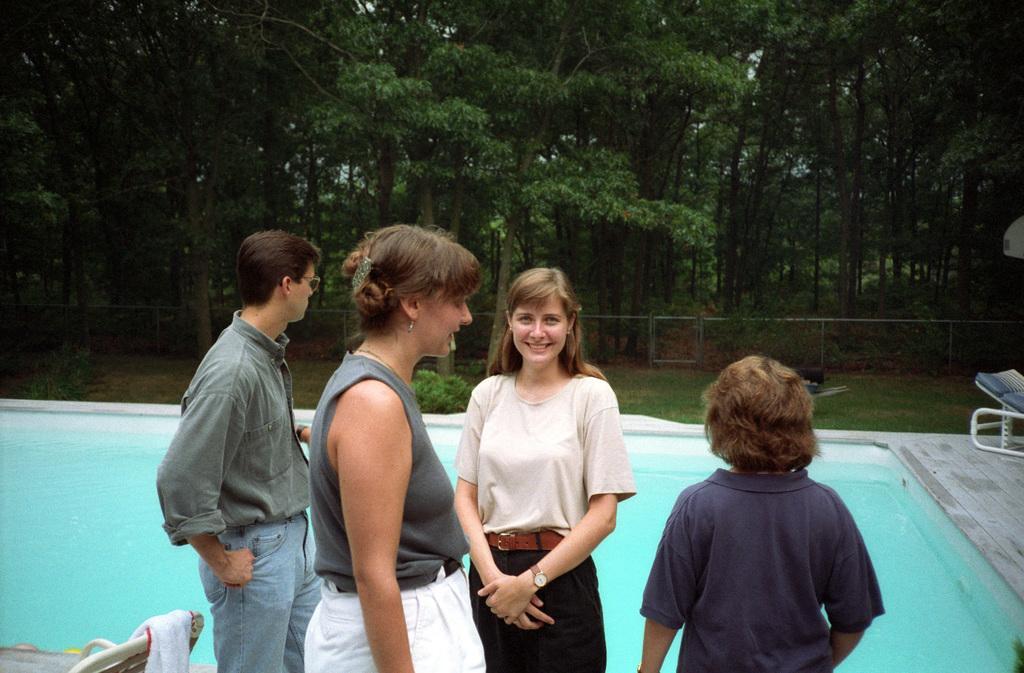Could you give a brief overview of what you see in this image? In this image in the foreground there are some people who are standing, and in the background there is a swimming pool, chairs, railing and some trees. At the bottom there is one chair, on the chair there is one cloth. 